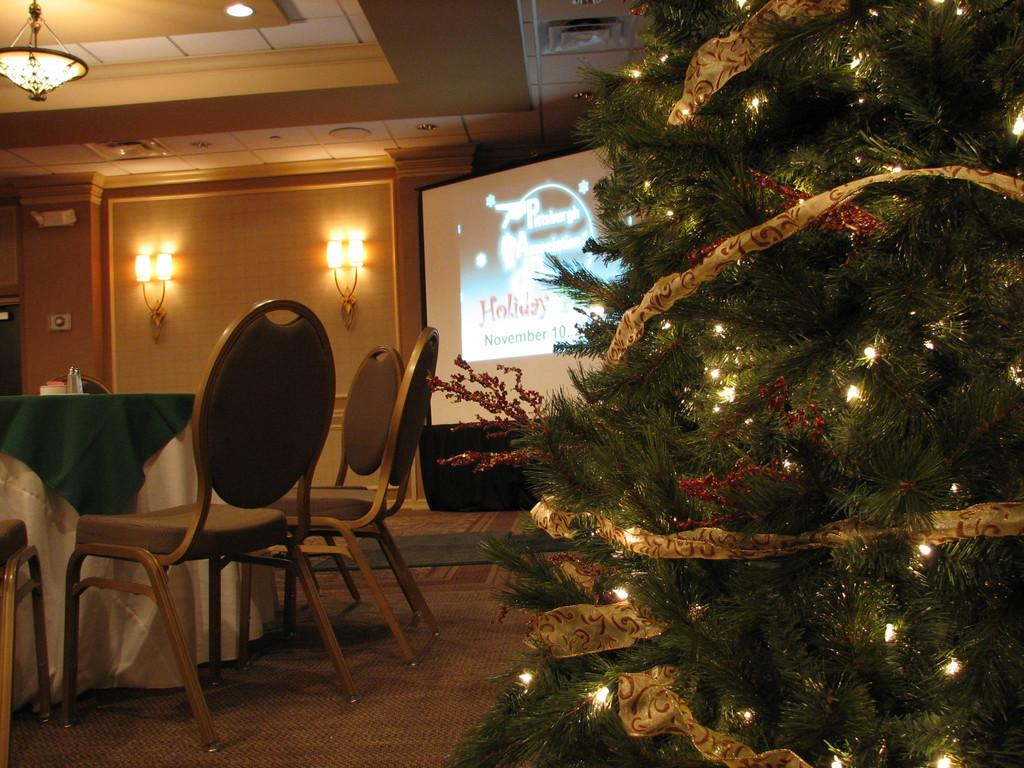What type of tree is decorated in the image? There is a Christmas tree with lights in the image. What type of furniture is present in the image? There are chairs and a table in the image. Are there any additional light sources in the image? Yes, there are lights on the wall in the image. What might be used for displaying information or entertainment in the image? There is a screen in the image. What is the income of the actor sitting on the chair in the image? There is no actor present in the image, and therefore no income can be determined. 